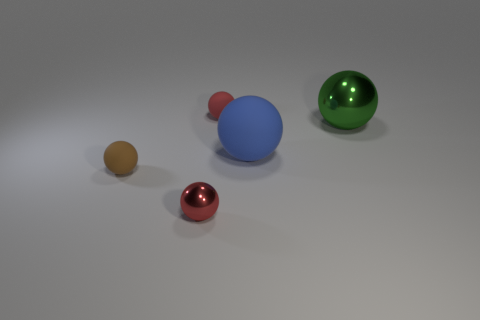Subtract all blue balls. How many balls are left? 4 Subtract all red rubber spheres. How many spheres are left? 4 Subtract all blue spheres. Subtract all brown cylinders. How many spheres are left? 4 Add 3 tiny objects. How many objects exist? 8 Add 5 tiny cyan metallic cylinders. How many tiny cyan metallic cylinders exist? 5 Subtract 0 purple cylinders. How many objects are left? 5 Subtract all small metallic objects. Subtract all metallic spheres. How many objects are left? 2 Add 5 green metal spheres. How many green metal spheres are left? 6 